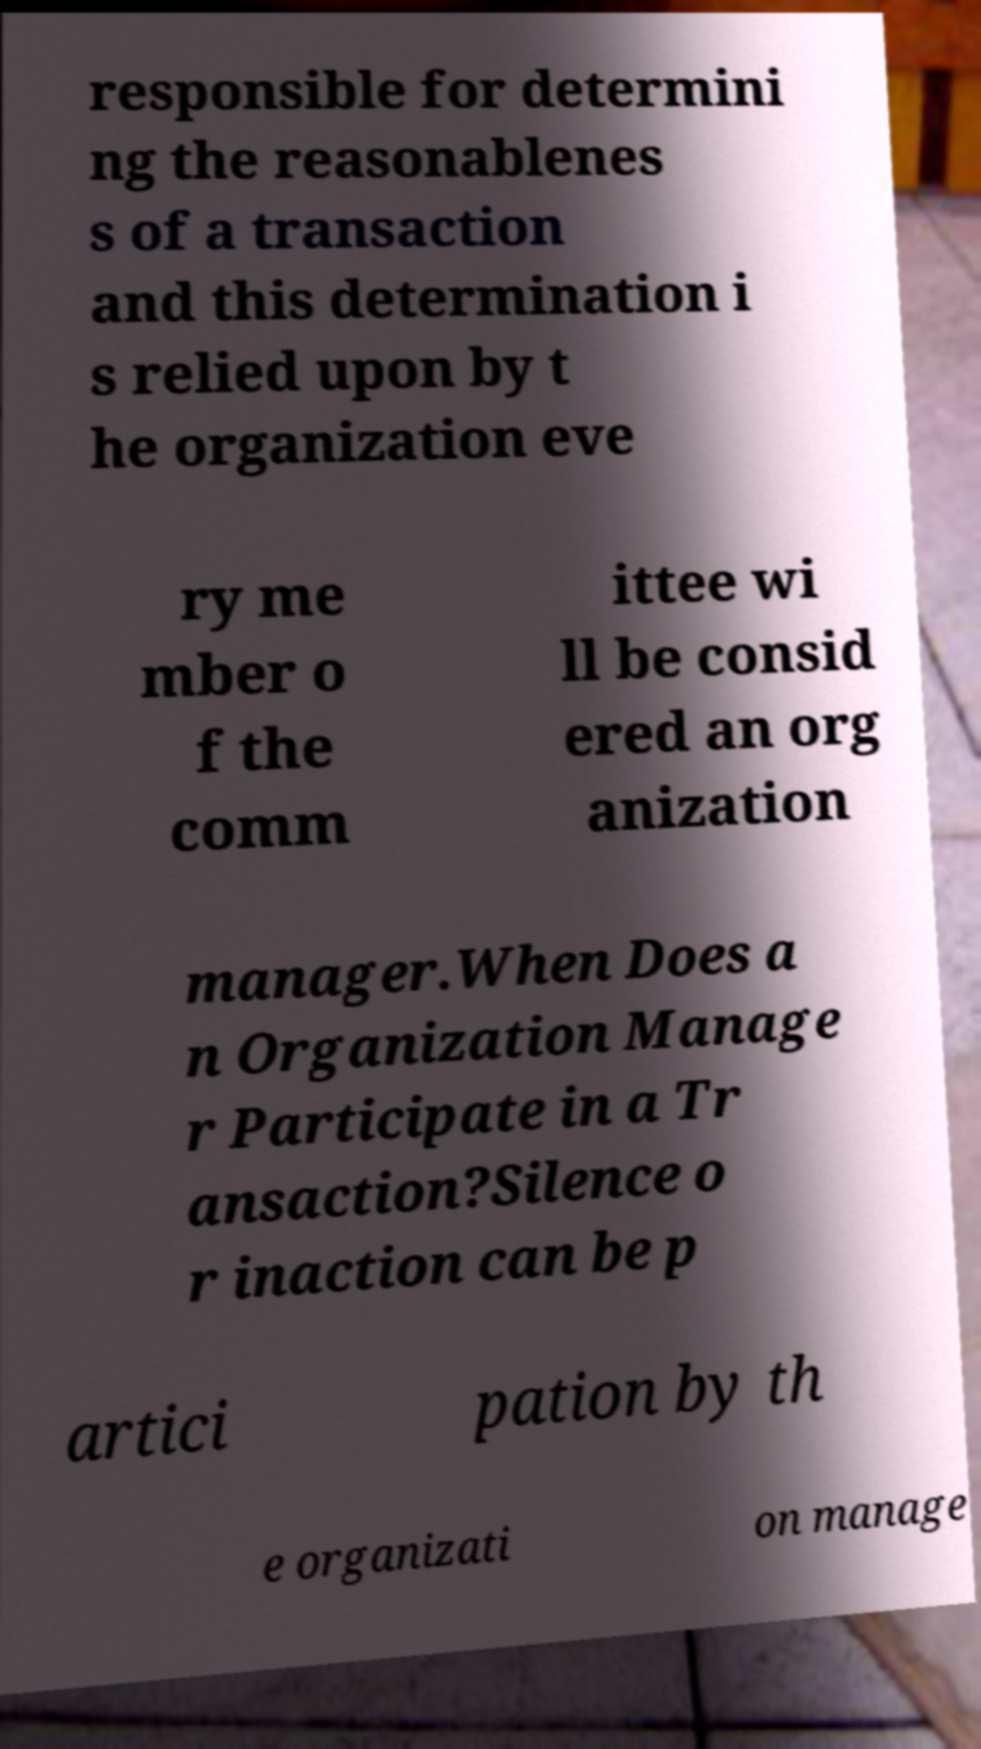Could you extract and type out the text from this image? responsible for determini ng the reasonablenes s of a transaction and this determination i s relied upon by t he organization eve ry me mber o f the comm ittee wi ll be consid ered an org anization manager.When Does a n Organization Manage r Participate in a Tr ansaction?Silence o r inaction can be p artici pation by th e organizati on manage 